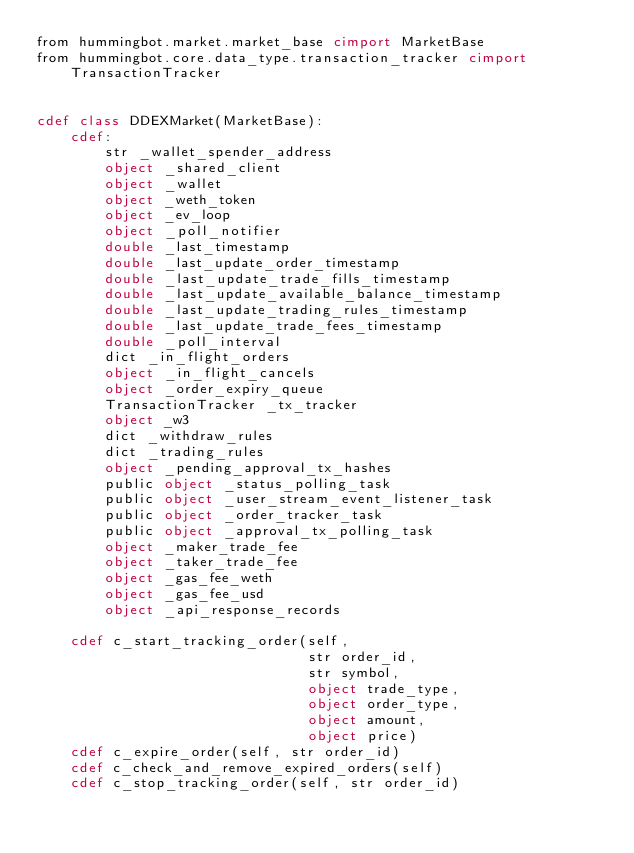Convert code to text. <code><loc_0><loc_0><loc_500><loc_500><_Cython_>from hummingbot.market.market_base cimport MarketBase
from hummingbot.core.data_type.transaction_tracker cimport TransactionTracker


cdef class DDEXMarket(MarketBase):
    cdef:
        str _wallet_spender_address
        object _shared_client
        object _wallet
        object _weth_token
        object _ev_loop
        object _poll_notifier
        double _last_timestamp
        double _last_update_order_timestamp
        double _last_update_trade_fills_timestamp
        double _last_update_available_balance_timestamp
        double _last_update_trading_rules_timestamp
        double _last_update_trade_fees_timestamp
        double _poll_interval
        dict _in_flight_orders
        object _in_flight_cancels
        object _order_expiry_queue
        TransactionTracker _tx_tracker
        object _w3
        dict _withdraw_rules
        dict _trading_rules
        object _pending_approval_tx_hashes
        public object _status_polling_task
        public object _user_stream_event_listener_task
        public object _order_tracker_task
        public object _approval_tx_polling_task
        object _maker_trade_fee
        object _taker_trade_fee
        object _gas_fee_weth
        object _gas_fee_usd
        object _api_response_records

    cdef c_start_tracking_order(self,
                                str order_id,
                                str symbol,
                                object trade_type,
                                object order_type,
                                object amount,
                                object price)
    cdef c_expire_order(self, str order_id)
    cdef c_check_and_remove_expired_orders(self)
    cdef c_stop_tracking_order(self, str order_id)
</code> 